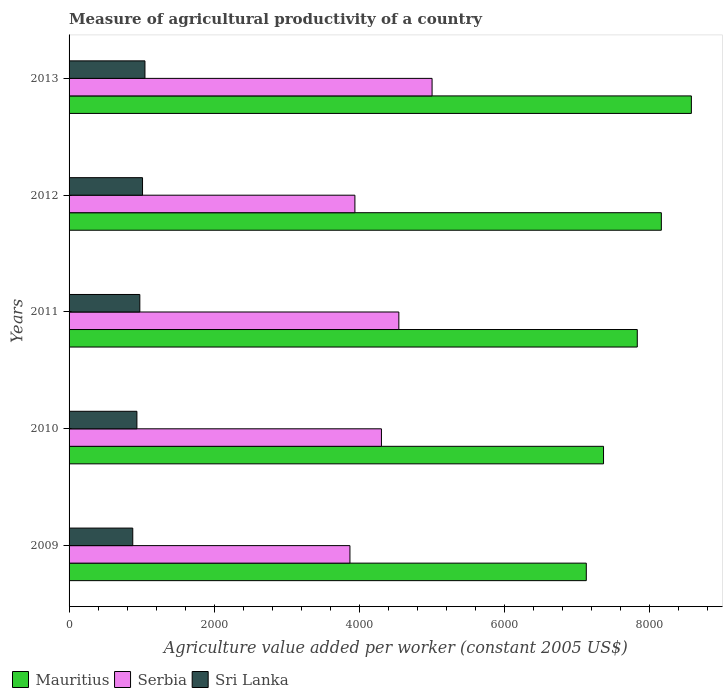How many different coloured bars are there?
Your response must be concise. 3. How many groups of bars are there?
Provide a short and direct response. 5. Are the number of bars on each tick of the Y-axis equal?
Provide a short and direct response. Yes. How many bars are there on the 2nd tick from the top?
Offer a terse response. 3. How many bars are there on the 1st tick from the bottom?
Your response must be concise. 3. In how many cases, is the number of bars for a given year not equal to the number of legend labels?
Your response must be concise. 0. What is the measure of agricultural productivity in Serbia in 2012?
Make the answer very short. 3938.29. Across all years, what is the maximum measure of agricultural productivity in Serbia?
Give a very brief answer. 5001.63. Across all years, what is the minimum measure of agricultural productivity in Mauritius?
Offer a very short reply. 7126.5. In which year was the measure of agricultural productivity in Sri Lanka maximum?
Provide a succinct answer. 2013. In which year was the measure of agricultural productivity in Sri Lanka minimum?
Your answer should be very brief. 2009. What is the total measure of agricultural productivity in Serbia in the graph?
Provide a short and direct response. 2.17e+04. What is the difference between the measure of agricultural productivity in Serbia in 2009 and that in 2012?
Offer a terse response. -68.27. What is the difference between the measure of agricultural productivity in Mauritius in 2013 and the measure of agricultural productivity in Sri Lanka in 2012?
Your response must be concise. 7562.35. What is the average measure of agricultural productivity in Mauritius per year?
Provide a succinct answer. 7810.95. In the year 2010, what is the difference between the measure of agricultural productivity in Sri Lanka and measure of agricultural productivity in Serbia?
Give a very brief answer. -3369.41. What is the ratio of the measure of agricultural productivity in Serbia in 2009 to that in 2013?
Make the answer very short. 0.77. Is the measure of agricultural productivity in Mauritius in 2011 less than that in 2012?
Your answer should be compact. Yes. Is the difference between the measure of agricultural productivity in Sri Lanka in 2012 and 2013 greater than the difference between the measure of agricultural productivity in Serbia in 2012 and 2013?
Offer a terse response. Yes. What is the difference between the highest and the second highest measure of agricultural productivity in Serbia?
Make the answer very short. 457.96. What is the difference between the highest and the lowest measure of agricultural productivity in Sri Lanka?
Offer a very short reply. 167.9. Is the sum of the measure of agricultural productivity in Serbia in 2012 and 2013 greater than the maximum measure of agricultural productivity in Mauritius across all years?
Ensure brevity in your answer.  Yes. What does the 3rd bar from the top in 2012 represents?
Your answer should be compact. Mauritius. What does the 3rd bar from the bottom in 2010 represents?
Provide a short and direct response. Sri Lanka. Is it the case that in every year, the sum of the measure of agricultural productivity in Sri Lanka and measure of agricultural productivity in Serbia is greater than the measure of agricultural productivity in Mauritius?
Provide a short and direct response. No. How many bars are there?
Give a very brief answer. 15. What is the difference between two consecutive major ticks on the X-axis?
Ensure brevity in your answer.  2000. How are the legend labels stacked?
Keep it short and to the point. Horizontal. What is the title of the graph?
Your answer should be very brief. Measure of agricultural productivity of a country. Does "Burundi" appear as one of the legend labels in the graph?
Provide a short and direct response. No. What is the label or title of the X-axis?
Your response must be concise. Agriculture value added per worker (constant 2005 US$). What is the label or title of the Y-axis?
Keep it short and to the point. Years. What is the Agriculture value added per worker (constant 2005 US$) in Mauritius in 2009?
Make the answer very short. 7126.5. What is the Agriculture value added per worker (constant 2005 US$) of Serbia in 2009?
Ensure brevity in your answer.  3870.01. What is the Agriculture value added per worker (constant 2005 US$) of Sri Lanka in 2009?
Offer a terse response. 877.53. What is the Agriculture value added per worker (constant 2005 US$) in Mauritius in 2010?
Ensure brevity in your answer.  7364.05. What is the Agriculture value added per worker (constant 2005 US$) of Serbia in 2010?
Offer a terse response. 4303.98. What is the Agriculture value added per worker (constant 2005 US$) of Sri Lanka in 2010?
Keep it short and to the point. 934.57. What is the Agriculture value added per worker (constant 2005 US$) of Mauritius in 2011?
Your answer should be compact. 7829.09. What is the Agriculture value added per worker (constant 2005 US$) of Serbia in 2011?
Offer a terse response. 4543.67. What is the Agriculture value added per worker (constant 2005 US$) in Sri Lanka in 2011?
Your answer should be very brief. 974.85. What is the Agriculture value added per worker (constant 2005 US$) in Mauritius in 2012?
Provide a short and direct response. 8160.69. What is the Agriculture value added per worker (constant 2005 US$) in Serbia in 2012?
Ensure brevity in your answer.  3938.29. What is the Agriculture value added per worker (constant 2005 US$) in Sri Lanka in 2012?
Ensure brevity in your answer.  1012.07. What is the Agriculture value added per worker (constant 2005 US$) in Mauritius in 2013?
Make the answer very short. 8574.42. What is the Agriculture value added per worker (constant 2005 US$) in Serbia in 2013?
Ensure brevity in your answer.  5001.63. What is the Agriculture value added per worker (constant 2005 US$) in Sri Lanka in 2013?
Make the answer very short. 1045.43. Across all years, what is the maximum Agriculture value added per worker (constant 2005 US$) in Mauritius?
Your answer should be compact. 8574.42. Across all years, what is the maximum Agriculture value added per worker (constant 2005 US$) in Serbia?
Offer a very short reply. 5001.63. Across all years, what is the maximum Agriculture value added per worker (constant 2005 US$) of Sri Lanka?
Ensure brevity in your answer.  1045.43. Across all years, what is the minimum Agriculture value added per worker (constant 2005 US$) in Mauritius?
Your answer should be very brief. 7126.5. Across all years, what is the minimum Agriculture value added per worker (constant 2005 US$) in Serbia?
Provide a short and direct response. 3870.01. Across all years, what is the minimum Agriculture value added per worker (constant 2005 US$) in Sri Lanka?
Your answer should be compact. 877.53. What is the total Agriculture value added per worker (constant 2005 US$) in Mauritius in the graph?
Offer a terse response. 3.91e+04. What is the total Agriculture value added per worker (constant 2005 US$) of Serbia in the graph?
Provide a succinct answer. 2.17e+04. What is the total Agriculture value added per worker (constant 2005 US$) of Sri Lanka in the graph?
Make the answer very short. 4844.46. What is the difference between the Agriculture value added per worker (constant 2005 US$) of Mauritius in 2009 and that in 2010?
Make the answer very short. -237.55. What is the difference between the Agriculture value added per worker (constant 2005 US$) of Serbia in 2009 and that in 2010?
Give a very brief answer. -433.96. What is the difference between the Agriculture value added per worker (constant 2005 US$) of Sri Lanka in 2009 and that in 2010?
Provide a short and direct response. -57.04. What is the difference between the Agriculture value added per worker (constant 2005 US$) in Mauritius in 2009 and that in 2011?
Your answer should be compact. -702.58. What is the difference between the Agriculture value added per worker (constant 2005 US$) in Serbia in 2009 and that in 2011?
Your answer should be very brief. -673.66. What is the difference between the Agriculture value added per worker (constant 2005 US$) in Sri Lanka in 2009 and that in 2011?
Your answer should be compact. -97.32. What is the difference between the Agriculture value added per worker (constant 2005 US$) of Mauritius in 2009 and that in 2012?
Provide a succinct answer. -1034.19. What is the difference between the Agriculture value added per worker (constant 2005 US$) of Serbia in 2009 and that in 2012?
Ensure brevity in your answer.  -68.27. What is the difference between the Agriculture value added per worker (constant 2005 US$) of Sri Lanka in 2009 and that in 2012?
Provide a succinct answer. -134.53. What is the difference between the Agriculture value added per worker (constant 2005 US$) of Mauritius in 2009 and that in 2013?
Your answer should be compact. -1447.92. What is the difference between the Agriculture value added per worker (constant 2005 US$) in Serbia in 2009 and that in 2013?
Give a very brief answer. -1131.61. What is the difference between the Agriculture value added per worker (constant 2005 US$) in Sri Lanka in 2009 and that in 2013?
Provide a succinct answer. -167.9. What is the difference between the Agriculture value added per worker (constant 2005 US$) in Mauritius in 2010 and that in 2011?
Your response must be concise. -465.03. What is the difference between the Agriculture value added per worker (constant 2005 US$) of Serbia in 2010 and that in 2011?
Offer a terse response. -239.69. What is the difference between the Agriculture value added per worker (constant 2005 US$) of Sri Lanka in 2010 and that in 2011?
Give a very brief answer. -40.28. What is the difference between the Agriculture value added per worker (constant 2005 US$) of Mauritius in 2010 and that in 2012?
Ensure brevity in your answer.  -796.64. What is the difference between the Agriculture value added per worker (constant 2005 US$) in Serbia in 2010 and that in 2012?
Your answer should be compact. 365.69. What is the difference between the Agriculture value added per worker (constant 2005 US$) in Sri Lanka in 2010 and that in 2012?
Keep it short and to the point. -77.49. What is the difference between the Agriculture value added per worker (constant 2005 US$) of Mauritius in 2010 and that in 2013?
Your response must be concise. -1210.37. What is the difference between the Agriculture value added per worker (constant 2005 US$) in Serbia in 2010 and that in 2013?
Give a very brief answer. -697.65. What is the difference between the Agriculture value added per worker (constant 2005 US$) of Sri Lanka in 2010 and that in 2013?
Provide a short and direct response. -110.86. What is the difference between the Agriculture value added per worker (constant 2005 US$) of Mauritius in 2011 and that in 2012?
Give a very brief answer. -331.61. What is the difference between the Agriculture value added per worker (constant 2005 US$) in Serbia in 2011 and that in 2012?
Provide a short and direct response. 605.38. What is the difference between the Agriculture value added per worker (constant 2005 US$) in Sri Lanka in 2011 and that in 2012?
Your answer should be very brief. -37.21. What is the difference between the Agriculture value added per worker (constant 2005 US$) in Mauritius in 2011 and that in 2013?
Ensure brevity in your answer.  -745.33. What is the difference between the Agriculture value added per worker (constant 2005 US$) in Serbia in 2011 and that in 2013?
Your response must be concise. -457.96. What is the difference between the Agriculture value added per worker (constant 2005 US$) in Sri Lanka in 2011 and that in 2013?
Your answer should be very brief. -70.58. What is the difference between the Agriculture value added per worker (constant 2005 US$) in Mauritius in 2012 and that in 2013?
Give a very brief answer. -413.73. What is the difference between the Agriculture value added per worker (constant 2005 US$) in Serbia in 2012 and that in 2013?
Your answer should be very brief. -1063.34. What is the difference between the Agriculture value added per worker (constant 2005 US$) in Sri Lanka in 2012 and that in 2013?
Your answer should be compact. -33.37. What is the difference between the Agriculture value added per worker (constant 2005 US$) in Mauritius in 2009 and the Agriculture value added per worker (constant 2005 US$) in Serbia in 2010?
Your answer should be compact. 2822.53. What is the difference between the Agriculture value added per worker (constant 2005 US$) in Mauritius in 2009 and the Agriculture value added per worker (constant 2005 US$) in Sri Lanka in 2010?
Offer a terse response. 6191.93. What is the difference between the Agriculture value added per worker (constant 2005 US$) in Serbia in 2009 and the Agriculture value added per worker (constant 2005 US$) in Sri Lanka in 2010?
Your response must be concise. 2935.44. What is the difference between the Agriculture value added per worker (constant 2005 US$) of Mauritius in 2009 and the Agriculture value added per worker (constant 2005 US$) of Serbia in 2011?
Your answer should be very brief. 2582.84. What is the difference between the Agriculture value added per worker (constant 2005 US$) in Mauritius in 2009 and the Agriculture value added per worker (constant 2005 US$) in Sri Lanka in 2011?
Ensure brevity in your answer.  6151.65. What is the difference between the Agriculture value added per worker (constant 2005 US$) of Serbia in 2009 and the Agriculture value added per worker (constant 2005 US$) of Sri Lanka in 2011?
Your answer should be very brief. 2895.16. What is the difference between the Agriculture value added per worker (constant 2005 US$) in Mauritius in 2009 and the Agriculture value added per worker (constant 2005 US$) in Serbia in 2012?
Your answer should be very brief. 3188.22. What is the difference between the Agriculture value added per worker (constant 2005 US$) in Mauritius in 2009 and the Agriculture value added per worker (constant 2005 US$) in Sri Lanka in 2012?
Provide a short and direct response. 6114.44. What is the difference between the Agriculture value added per worker (constant 2005 US$) in Serbia in 2009 and the Agriculture value added per worker (constant 2005 US$) in Sri Lanka in 2012?
Ensure brevity in your answer.  2857.95. What is the difference between the Agriculture value added per worker (constant 2005 US$) of Mauritius in 2009 and the Agriculture value added per worker (constant 2005 US$) of Serbia in 2013?
Keep it short and to the point. 2124.88. What is the difference between the Agriculture value added per worker (constant 2005 US$) of Mauritius in 2009 and the Agriculture value added per worker (constant 2005 US$) of Sri Lanka in 2013?
Ensure brevity in your answer.  6081.07. What is the difference between the Agriculture value added per worker (constant 2005 US$) in Serbia in 2009 and the Agriculture value added per worker (constant 2005 US$) in Sri Lanka in 2013?
Ensure brevity in your answer.  2824.58. What is the difference between the Agriculture value added per worker (constant 2005 US$) in Mauritius in 2010 and the Agriculture value added per worker (constant 2005 US$) in Serbia in 2011?
Keep it short and to the point. 2820.39. What is the difference between the Agriculture value added per worker (constant 2005 US$) in Mauritius in 2010 and the Agriculture value added per worker (constant 2005 US$) in Sri Lanka in 2011?
Offer a very short reply. 6389.2. What is the difference between the Agriculture value added per worker (constant 2005 US$) of Serbia in 2010 and the Agriculture value added per worker (constant 2005 US$) of Sri Lanka in 2011?
Make the answer very short. 3329.13. What is the difference between the Agriculture value added per worker (constant 2005 US$) in Mauritius in 2010 and the Agriculture value added per worker (constant 2005 US$) in Serbia in 2012?
Ensure brevity in your answer.  3425.77. What is the difference between the Agriculture value added per worker (constant 2005 US$) in Mauritius in 2010 and the Agriculture value added per worker (constant 2005 US$) in Sri Lanka in 2012?
Provide a succinct answer. 6351.99. What is the difference between the Agriculture value added per worker (constant 2005 US$) in Serbia in 2010 and the Agriculture value added per worker (constant 2005 US$) in Sri Lanka in 2012?
Provide a succinct answer. 3291.91. What is the difference between the Agriculture value added per worker (constant 2005 US$) of Mauritius in 2010 and the Agriculture value added per worker (constant 2005 US$) of Serbia in 2013?
Your answer should be very brief. 2362.43. What is the difference between the Agriculture value added per worker (constant 2005 US$) of Mauritius in 2010 and the Agriculture value added per worker (constant 2005 US$) of Sri Lanka in 2013?
Provide a short and direct response. 6318.62. What is the difference between the Agriculture value added per worker (constant 2005 US$) of Serbia in 2010 and the Agriculture value added per worker (constant 2005 US$) of Sri Lanka in 2013?
Give a very brief answer. 3258.54. What is the difference between the Agriculture value added per worker (constant 2005 US$) of Mauritius in 2011 and the Agriculture value added per worker (constant 2005 US$) of Serbia in 2012?
Ensure brevity in your answer.  3890.8. What is the difference between the Agriculture value added per worker (constant 2005 US$) of Mauritius in 2011 and the Agriculture value added per worker (constant 2005 US$) of Sri Lanka in 2012?
Make the answer very short. 6817.02. What is the difference between the Agriculture value added per worker (constant 2005 US$) of Serbia in 2011 and the Agriculture value added per worker (constant 2005 US$) of Sri Lanka in 2012?
Provide a succinct answer. 3531.6. What is the difference between the Agriculture value added per worker (constant 2005 US$) in Mauritius in 2011 and the Agriculture value added per worker (constant 2005 US$) in Serbia in 2013?
Provide a short and direct response. 2827.46. What is the difference between the Agriculture value added per worker (constant 2005 US$) in Mauritius in 2011 and the Agriculture value added per worker (constant 2005 US$) in Sri Lanka in 2013?
Provide a succinct answer. 6783.65. What is the difference between the Agriculture value added per worker (constant 2005 US$) of Serbia in 2011 and the Agriculture value added per worker (constant 2005 US$) of Sri Lanka in 2013?
Offer a terse response. 3498.23. What is the difference between the Agriculture value added per worker (constant 2005 US$) in Mauritius in 2012 and the Agriculture value added per worker (constant 2005 US$) in Serbia in 2013?
Offer a very short reply. 3159.07. What is the difference between the Agriculture value added per worker (constant 2005 US$) in Mauritius in 2012 and the Agriculture value added per worker (constant 2005 US$) in Sri Lanka in 2013?
Provide a succinct answer. 7115.26. What is the difference between the Agriculture value added per worker (constant 2005 US$) in Serbia in 2012 and the Agriculture value added per worker (constant 2005 US$) in Sri Lanka in 2013?
Offer a terse response. 2892.85. What is the average Agriculture value added per worker (constant 2005 US$) of Mauritius per year?
Your response must be concise. 7810.95. What is the average Agriculture value added per worker (constant 2005 US$) in Serbia per year?
Keep it short and to the point. 4331.51. What is the average Agriculture value added per worker (constant 2005 US$) in Sri Lanka per year?
Keep it short and to the point. 968.89. In the year 2009, what is the difference between the Agriculture value added per worker (constant 2005 US$) of Mauritius and Agriculture value added per worker (constant 2005 US$) of Serbia?
Provide a succinct answer. 3256.49. In the year 2009, what is the difference between the Agriculture value added per worker (constant 2005 US$) in Mauritius and Agriculture value added per worker (constant 2005 US$) in Sri Lanka?
Ensure brevity in your answer.  6248.97. In the year 2009, what is the difference between the Agriculture value added per worker (constant 2005 US$) of Serbia and Agriculture value added per worker (constant 2005 US$) of Sri Lanka?
Offer a very short reply. 2992.48. In the year 2010, what is the difference between the Agriculture value added per worker (constant 2005 US$) of Mauritius and Agriculture value added per worker (constant 2005 US$) of Serbia?
Your answer should be very brief. 3060.08. In the year 2010, what is the difference between the Agriculture value added per worker (constant 2005 US$) of Mauritius and Agriculture value added per worker (constant 2005 US$) of Sri Lanka?
Your response must be concise. 6429.48. In the year 2010, what is the difference between the Agriculture value added per worker (constant 2005 US$) of Serbia and Agriculture value added per worker (constant 2005 US$) of Sri Lanka?
Provide a short and direct response. 3369.41. In the year 2011, what is the difference between the Agriculture value added per worker (constant 2005 US$) of Mauritius and Agriculture value added per worker (constant 2005 US$) of Serbia?
Your answer should be very brief. 3285.42. In the year 2011, what is the difference between the Agriculture value added per worker (constant 2005 US$) in Mauritius and Agriculture value added per worker (constant 2005 US$) in Sri Lanka?
Offer a terse response. 6854.23. In the year 2011, what is the difference between the Agriculture value added per worker (constant 2005 US$) of Serbia and Agriculture value added per worker (constant 2005 US$) of Sri Lanka?
Your answer should be very brief. 3568.82. In the year 2012, what is the difference between the Agriculture value added per worker (constant 2005 US$) in Mauritius and Agriculture value added per worker (constant 2005 US$) in Serbia?
Provide a succinct answer. 4222.41. In the year 2012, what is the difference between the Agriculture value added per worker (constant 2005 US$) of Mauritius and Agriculture value added per worker (constant 2005 US$) of Sri Lanka?
Offer a terse response. 7148.63. In the year 2012, what is the difference between the Agriculture value added per worker (constant 2005 US$) of Serbia and Agriculture value added per worker (constant 2005 US$) of Sri Lanka?
Ensure brevity in your answer.  2926.22. In the year 2013, what is the difference between the Agriculture value added per worker (constant 2005 US$) of Mauritius and Agriculture value added per worker (constant 2005 US$) of Serbia?
Give a very brief answer. 3572.79. In the year 2013, what is the difference between the Agriculture value added per worker (constant 2005 US$) of Mauritius and Agriculture value added per worker (constant 2005 US$) of Sri Lanka?
Your answer should be very brief. 7528.99. In the year 2013, what is the difference between the Agriculture value added per worker (constant 2005 US$) of Serbia and Agriculture value added per worker (constant 2005 US$) of Sri Lanka?
Provide a succinct answer. 3956.19. What is the ratio of the Agriculture value added per worker (constant 2005 US$) of Mauritius in 2009 to that in 2010?
Your answer should be compact. 0.97. What is the ratio of the Agriculture value added per worker (constant 2005 US$) of Serbia in 2009 to that in 2010?
Your answer should be compact. 0.9. What is the ratio of the Agriculture value added per worker (constant 2005 US$) in Sri Lanka in 2009 to that in 2010?
Make the answer very short. 0.94. What is the ratio of the Agriculture value added per worker (constant 2005 US$) in Mauritius in 2009 to that in 2011?
Make the answer very short. 0.91. What is the ratio of the Agriculture value added per worker (constant 2005 US$) in Serbia in 2009 to that in 2011?
Make the answer very short. 0.85. What is the ratio of the Agriculture value added per worker (constant 2005 US$) of Sri Lanka in 2009 to that in 2011?
Your response must be concise. 0.9. What is the ratio of the Agriculture value added per worker (constant 2005 US$) of Mauritius in 2009 to that in 2012?
Ensure brevity in your answer.  0.87. What is the ratio of the Agriculture value added per worker (constant 2005 US$) in Serbia in 2009 to that in 2012?
Offer a terse response. 0.98. What is the ratio of the Agriculture value added per worker (constant 2005 US$) in Sri Lanka in 2009 to that in 2012?
Your answer should be compact. 0.87. What is the ratio of the Agriculture value added per worker (constant 2005 US$) in Mauritius in 2009 to that in 2013?
Offer a terse response. 0.83. What is the ratio of the Agriculture value added per worker (constant 2005 US$) of Serbia in 2009 to that in 2013?
Offer a terse response. 0.77. What is the ratio of the Agriculture value added per worker (constant 2005 US$) in Sri Lanka in 2009 to that in 2013?
Your answer should be very brief. 0.84. What is the ratio of the Agriculture value added per worker (constant 2005 US$) in Mauritius in 2010 to that in 2011?
Make the answer very short. 0.94. What is the ratio of the Agriculture value added per worker (constant 2005 US$) in Serbia in 2010 to that in 2011?
Your answer should be very brief. 0.95. What is the ratio of the Agriculture value added per worker (constant 2005 US$) in Sri Lanka in 2010 to that in 2011?
Keep it short and to the point. 0.96. What is the ratio of the Agriculture value added per worker (constant 2005 US$) of Mauritius in 2010 to that in 2012?
Provide a short and direct response. 0.9. What is the ratio of the Agriculture value added per worker (constant 2005 US$) in Serbia in 2010 to that in 2012?
Provide a succinct answer. 1.09. What is the ratio of the Agriculture value added per worker (constant 2005 US$) of Sri Lanka in 2010 to that in 2012?
Give a very brief answer. 0.92. What is the ratio of the Agriculture value added per worker (constant 2005 US$) in Mauritius in 2010 to that in 2013?
Your answer should be very brief. 0.86. What is the ratio of the Agriculture value added per worker (constant 2005 US$) in Serbia in 2010 to that in 2013?
Provide a short and direct response. 0.86. What is the ratio of the Agriculture value added per worker (constant 2005 US$) in Sri Lanka in 2010 to that in 2013?
Provide a succinct answer. 0.89. What is the ratio of the Agriculture value added per worker (constant 2005 US$) in Mauritius in 2011 to that in 2012?
Make the answer very short. 0.96. What is the ratio of the Agriculture value added per worker (constant 2005 US$) of Serbia in 2011 to that in 2012?
Your response must be concise. 1.15. What is the ratio of the Agriculture value added per worker (constant 2005 US$) of Sri Lanka in 2011 to that in 2012?
Offer a terse response. 0.96. What is the ratio of the Agriculture value added per worker (constant 2005 US$) of Mauritius in 2011 to that in 2013?
Provide a succinct answer. 0.91. What is the ratio of the Agriculture value added per worker (constant 2005 US$) in Serbia in 2011 to that in 2013?
Your answer should be very brief. 0.91. What is the ratio of the Agriculture value added per worker (constant 2005 US$) of Sri Lanka in 2011 to that in 2013?
Offer a very short reply. 0.93. What is the ratio of the Agriculture value added per worker (constant 2005 US$) of Mauritius in 2012 to that in 2013?
Offer a very short reply. 0.95. What is the ratio of the Agriculture value added per worker (constant 2005 US$) of Serbia in 2012 to that in 2013?
Provide a short and direct response. 0.79. What is the ratio of the Agriculture value added per worker (constant 2005 US$) of Sri Lanka in 2012 to that in 2013?
Give a very brief answer. 0.97. What is the difference between the highest and the second highest Agriculture value added per worker (constant 2005 US$) of Mauritius?
Your response must be concise. 413.73. What is the difference between the highest and the second highest Agriculture value added per worker (constant 2005 US$) in Serbia?
Offer a very short reply. 457.96. What is the difference between the highest and the second highest Agriculture value added per worker (constant 2005 US$) in Sri Lanka?
Offer a very short reply. 33.37. What is the difference between the highest and the lowest Agriculture value added per worker (constant 2005 US$) of Mauritius?
Keep it short and to the point. 1447.92. What is the difference between the highest and the lowest Agriculture value added per worker (constant 2005 US$) of Serbia?
Make the answer very short. 1131.61. What is the difference between the highest and the lowest Agriculture value added per worker (constant 2005 US$) of Sri Lanka?
Your answer should be very brief. 167.9. 